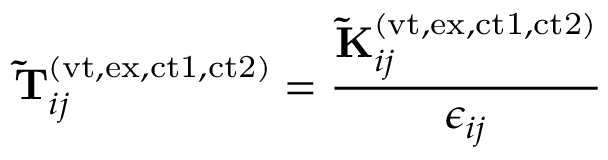<formula> <loc_0><loc_0><loc_500><loc_500>\widetilde { T } _ { i j } ^ { ( v t , e x , c t 1 , c t 2 ) } = \frac { \widetilde { K } _ { i j } ^ { ( v t , e x , c t 1 , c t 2 ) } } { \epsilon _ { i j } }</formula> 